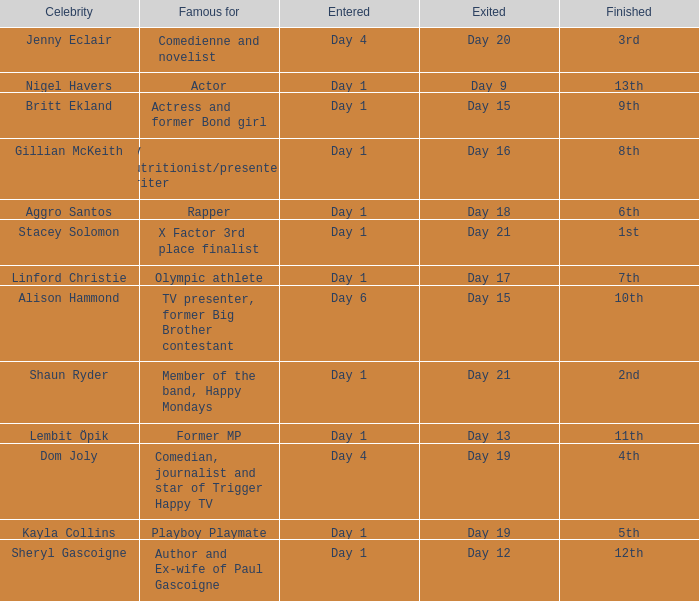What was Dom Joly famous for? Comedian, journalist and star of Trigger Happy TV. 